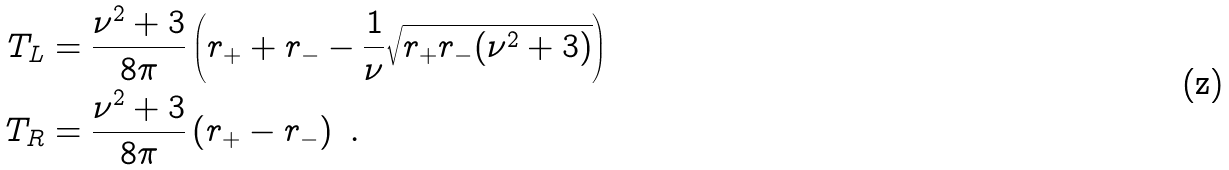Convert formula to latex. <formula><loc_0><loc_0><loc_500><loc_500>T _ { L } & = \frac { \nu ^ { 2 } + 3 } { 8 \pi } \left ( r _ { + } + r _ { - } - \frac { 1 } { \nu } \sqrt { r _ { + } r _ { - } ( \nu ^ { 2 } + 3 ) } \right ) \\ T _ { R } & = \frac { \nu ^ { 2 } + 3 } { 8 \pi } \left ( r _ { + } - r _ { - } \right ) \ .</formula> 